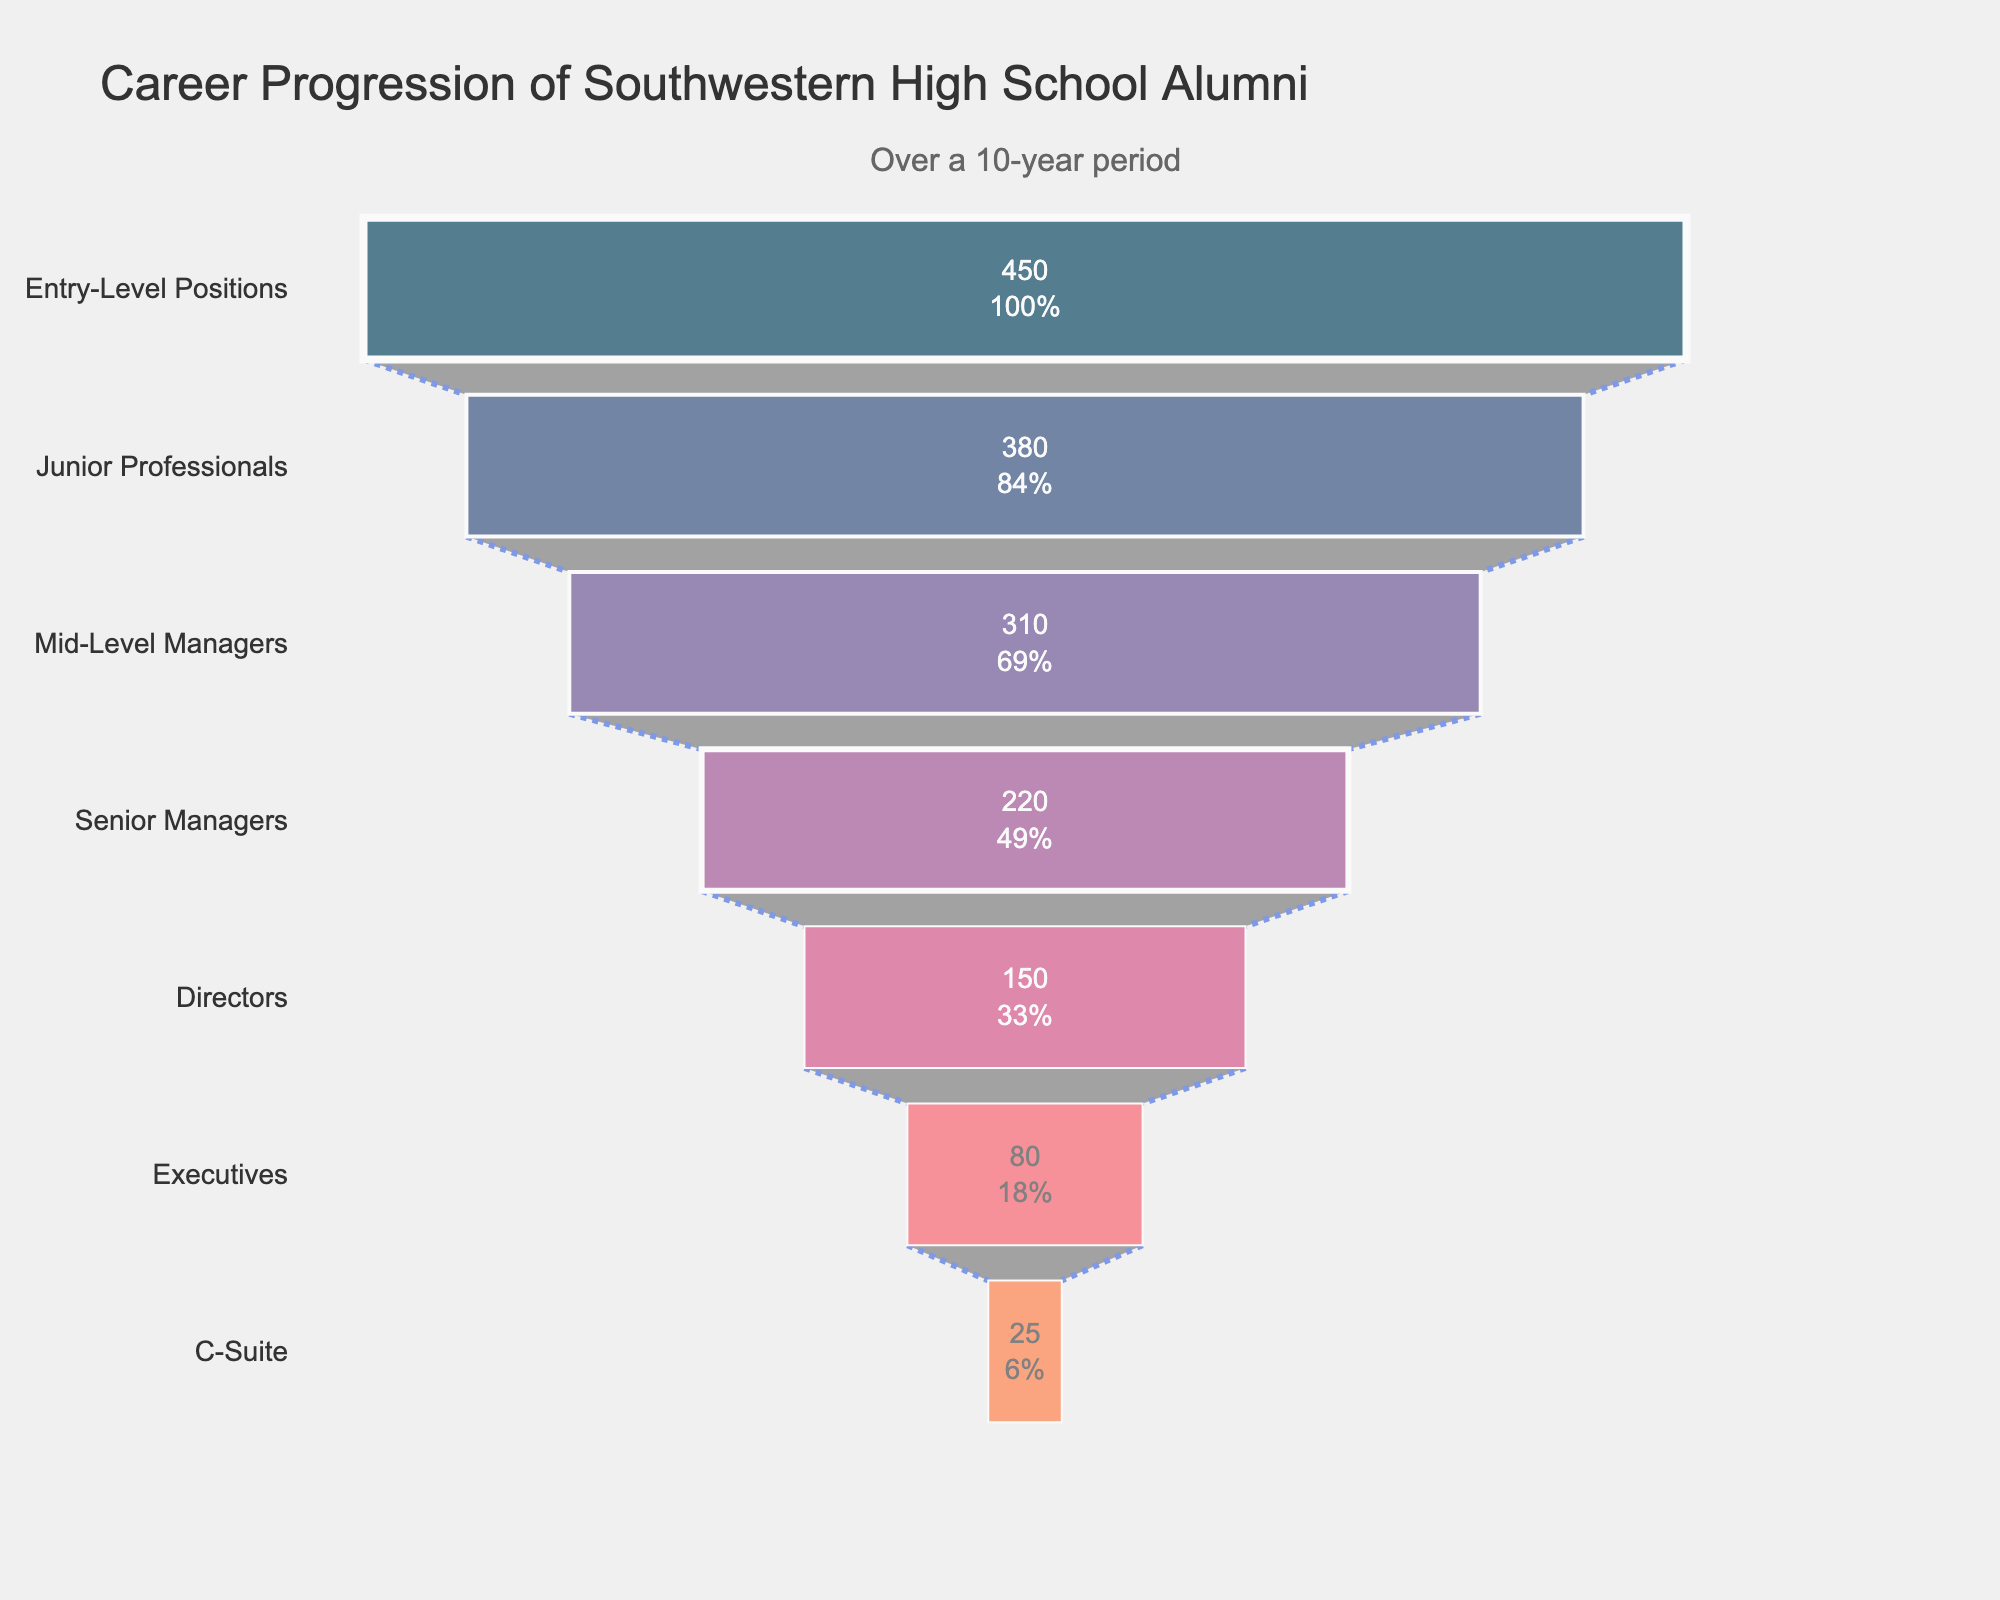How many alumni are in Entry-Level Positions? The number of alumni in Entry-Level Positions is provided directly in the figure. Refer to the corresponding stage in the funnel chart.
Answer: 450 What is the exact title of the figure? The title is usually displayed at the top of the chart.
Answer: Career Progression of Southwestern High School Alumni Which stage has the lowest number of alumni? The funnel chart will show the stages with the number of alumni, so look for the smallest number.
Answer: C-Suite How many more alumni are at the Entry-Level Positions stage compared to the C-Suite stage? Subtract the number of alumni in the C-Suite stage from those in the Entry-Level Positions stage. Calculation: 450 - 25 = 425
Answer: 425 What percentage of the total alumni is at the Executive stage? Find the total number of alumni by summing all the numbers. Then divide the number of Executives by this sum and multiply by 100. Total alumni = 450 + 380 + 310 + 220 + 150 + 80 + 25 = 1615. Percentage = (80 / 1615) * 100 ≈ 4.95%
Answer: 4.95% How does the number of alumni in Senior Managers compare to those in Junior Professionals? Compare the numbers directly to determine if there are more or fewer Senior Managers than Junior Professionals. Junior Professionals = 380, Senior Managers = 220. 220 < 380.
Answer: Fewer What is the difference in the number of alumni between Mid-Level Managers and Directors? Subtract the smaller number from the larger number. Mid-Level Managers = 310, Directors = 150. 310 - 150 = 160
Answer: 160 Can you calculate the sum of alumni from the Senior Managers and Executives stages? Add the number of alumni in Senior Managers and Executives stages. Calculation: 220 + 80 = 300
Answer: 300 Is there any stage where less than 100 alumni are present? If so, which one(s)? Check each number and note any stage with less than 100 alumni. Only the C-Suite stage has less than 100 alumni with 25 alumni.
Answer: C-Suite What is the average number of alumni per stage across all the stages in the chart? Calculate the total number of alumni and divide by the number of stages. Total alumni = 1615. Number of stages = 7. Average = 1615 / 7 ≈ 230.71
Answer: 230.71 